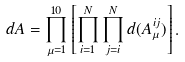Convert formula to latex. <formula><loc_0><loc_0><loc_500><loc_500>d A = \prod _ { \mu = 1 } ^ { 1 0 } \left [ \prod _ { i = 1 } ^ { N } \prod _ { j = i } ^ { N } d ( A _ { \mu } ^ { i j } ) \right ] .</formula> 